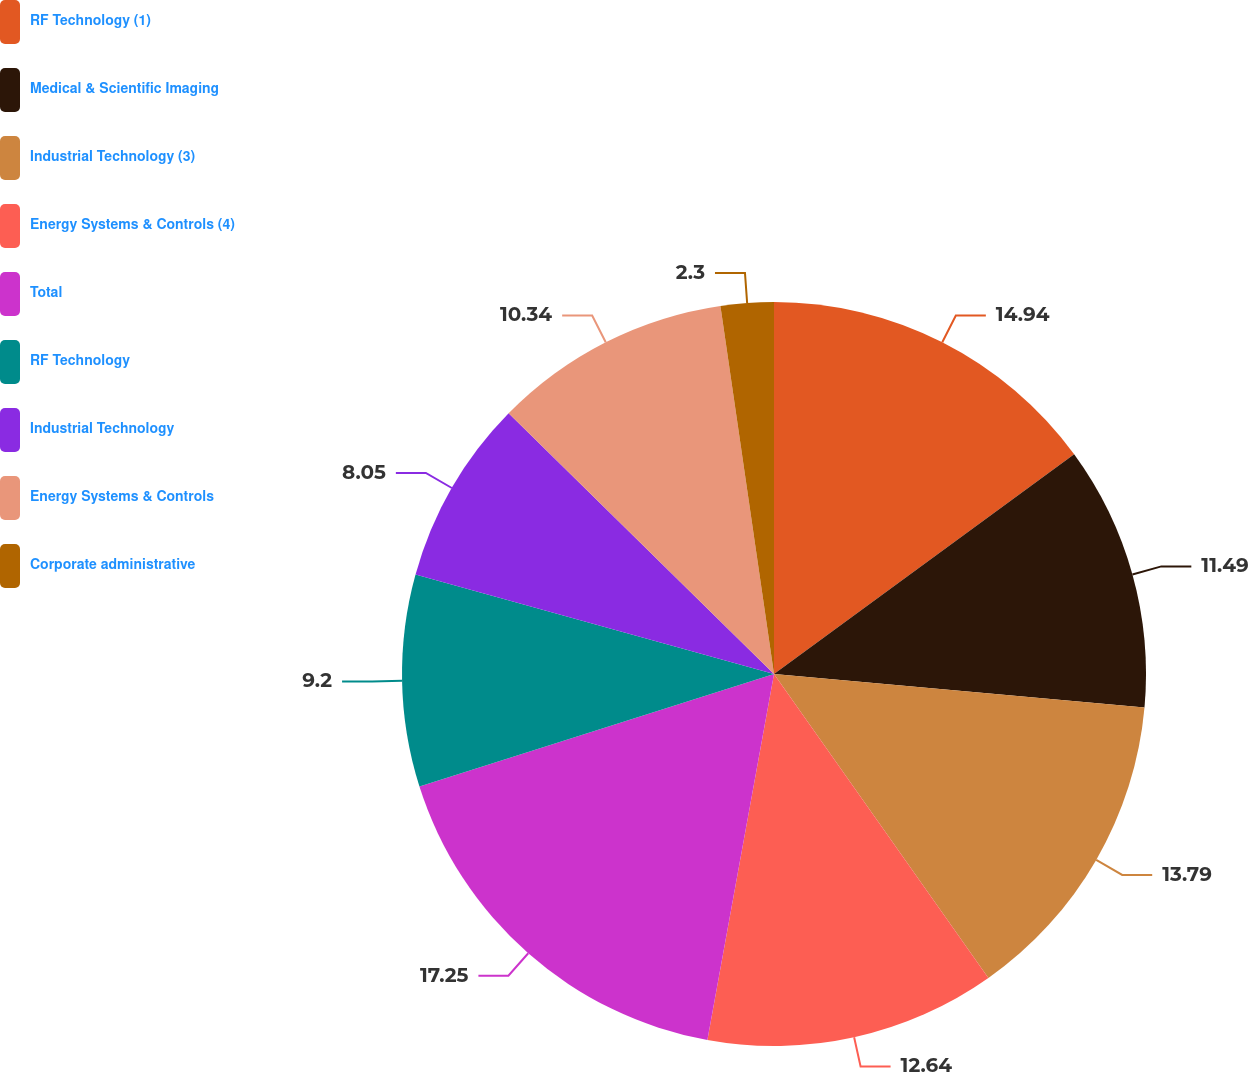<chart> <loc_0><loc_0><loc_500><loc_500><pie_chart><fcel>RF Technology (1)<fcel>Medical & Scientific Imaging<fcel>Industrial Technology (3)<fcel>Energy Systems & Controls (4)<fcel>Total<fcel>RF Technology<fcel>Industrial Technology<fcel>Energy Systems & Controls<fcel>Corporate administrative<nl><fcel>14.94%<fcel>11.49%<fcel>13.79%<fcel>12.64%<fcel>17.24%<fcel>9.2%<fcel>8.05%<fcel>10.34%<fcel>2.3%<nl></chart> 